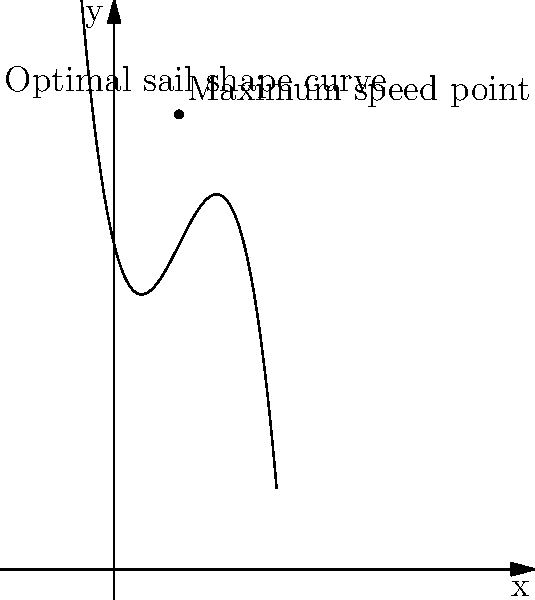As a sailing expert, you're tasked with determining the optimal sail shape for maximum speed. The sail's shape is represented by the polynomial function $f(x) = -0.5x^3 + 3x^2 - 4x + 10$, where $x$ is the horizontal distance from the mast and $f(x)$ is the sail's curvature. Find the x-coordinate of the point where the sail shape provides maximum speed. To find the point of maximum speed, we need to determine the maximum point of the polynomial function. This can be done by following these steps:

1) First, calculate the derivative of the function:
   $f'(x) = -1.5x^2 + 6x - 4$

2) Set the derivative equal to zero to find the critical points:
   $-1.5x^2 + 6x - 4 = 0$

3) This is a quadratic equation. We can solve it using the quadratic formula:
   $x = \frac{-b \pm \sqrt{b^2 - 4ac}}{2a}$

   Where $a = -1.5$, $b = 6$, and $c = -4$

4) Plugging these values into the quadratic formula:
   $x = \frac{-6 \pm \sqrt{36 - 4(-1.5)(-4)}}{2(-1.5)}$
   $= \frac{-6 \pm \sqrt{36 - 24}}{-3}$
   $= \frac{-6 \pm \sqrt{12}}{-3}$
   $= \frac{-6 \pm 2\sqrt{3}}{-3}$

5) This gives us two solutions:
   $x_1 = \frac{-6 + 2\sqrt{3}}{-3} = 2 - \frac{2\sqrt{3}}{3} \approx 0.845$
   $x_2 = \frac{-6 - 2\sqrt{3}}{-3} = 2 + \frac{2\sqrt{3}}{3} \approx 3.155$

6) To determine which of these is the maximum point, we can check the second derivative:
   $f''(x) = -3x + 6$

7) Evaluating $f''(x)$ at $x_1$ and $x_2$:
   $f''(0.845) \approx 3.465 > 0$
   $f''(3.155) \approx -3.465 < 0$

8) Since $f''(x_2) < 0$, $x_2$ is the maximum point.

Therefore, the x-coordinate of the point where the sail shape provides maximum speed is approximately 3.155.
Answer: $2 + \frac{2\sqrt{3}}{3}$ or approximately 3.155 